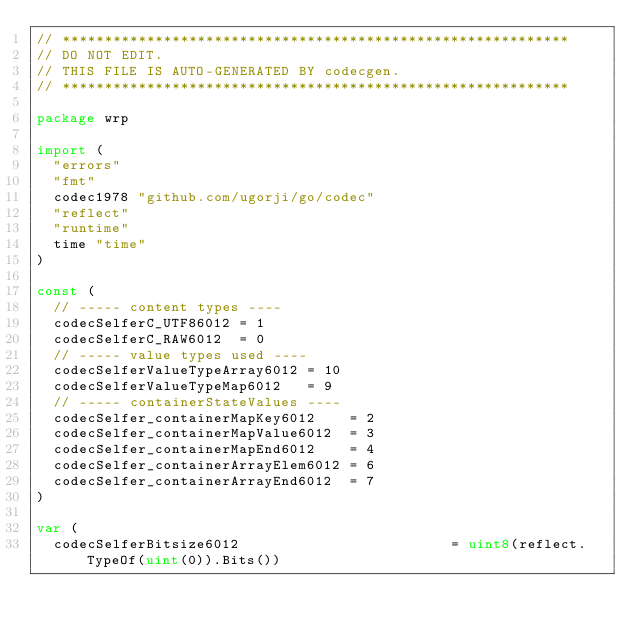Convert code to text. <code><loc_0><loc_0><loc_500><loc_500><_Go_>// ************************************************************
// DO NOT EDIT.
// THIS FILE IS AUTO-GENERATED BY codecgen.
// ************************************************************

package wrp

import (
	"errors"
	"fmt"
	codec1978 "github.com/ugorji/go/codec"
	"reflect"
	"runtime"
	time "time"
)

const (
	// ----- content types ----
	codecSelferC_UTF86012 = 1
	codecSelferC_RAW6012  = 0
	// ----- value types used ----
	codecSelferValueTypeArray6012 = 10
	codecSelferValueTypeMap6012   = 9
	// ----- containerStateValues ----
	codecSelfer_containerMapKey6012    = 2
	codecSelfer_containerMapValue6012  = 3
	codecSelfer_containerMapEnd6012    = 4
	codecSelfer_containerArrayElem6012 = 6
	codecSelfer_containerArrayEnd6012  = 7
)

var (
	codecSelferBitsize6012                         = uint8(reflect.TypeOf(uint(0)).Bits())</code> 